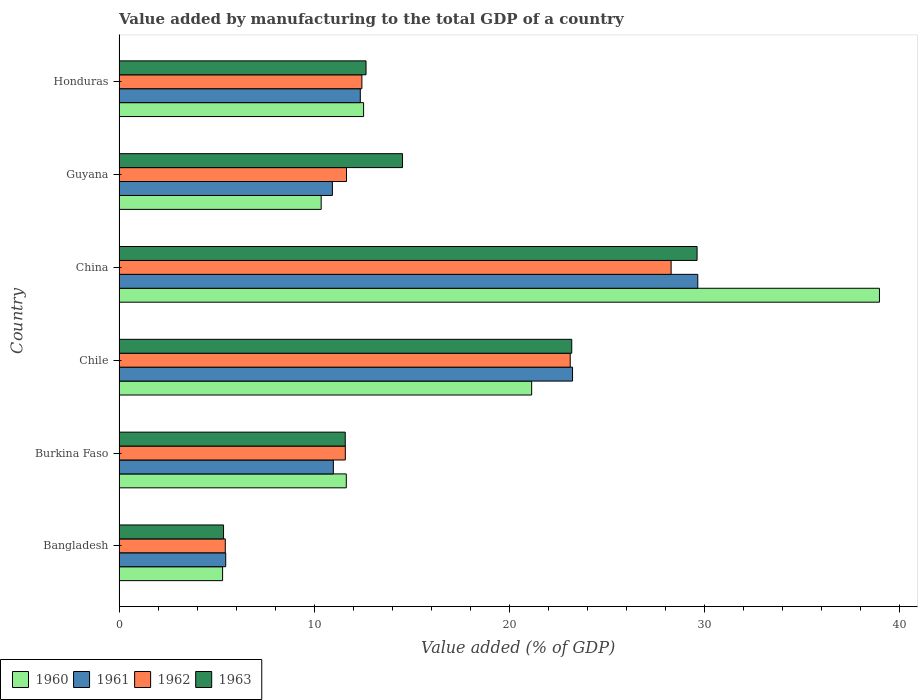How many groups of bars are there?
Make the answer very short. 6. Are the number of bars per tick equal to the number of legend labels?
Provide a succinct answer. Yes. How many bars are there on the 6th tick from the bottom?
Provide a short and direct response. 4. What is the label of the 5th group of bars from the top?
Provide a succinct answer. Burkina Faso. What is the value added by manufacturing to the total GDP in 1961 in Bangladesh?
Your answer should be compact. 5.47. Across all countries, what is the maximum value added by manufacturing to the total GDP in 1962?
Give a very brief answer. 28.31. Across all countries, what is the minimum value added by manufacturing to the total GDP in 1963?
Your answer should be compact. 5.36. What is the total value added by manufacturing to the total GDP in 1963 in the graph?
Ensure brevity in your answer.  97.02. What is the difference between the value added by manufacturing to the total GDP in 1961 in Chile and that in Guyana?
Give a very brief answer. 12.32. What is the difference between the value added by manufacturing to the total GDP in 1963 in Chile and the value added by manufacturing to the total GDP in 1961 in China?
Offer a very short reply. -6.46. What is the average value added by manufacturing to the total GDP in 1961 per country?
Provide a succinct answer. 15.45. What is the difference between the value added by manufacturing to the total GDP in 1960 and value added by manufacturing to the total GDP in 1961 in Guyana?
Your answer should be compact. -0.58. In how many countries, is the value added by manufacturing to the total GDP in 1963 greater than 38 %?
Ensure brevity in your answer.  0. What is the ratio of the value added by manufacturing to the total GDP in 1961 in Guyana to that in Honduras?
Offer a terse response. 0.88. Is the value added by manufacturing to the total GDP in 1963 in Bangladesh less than that in Chile?
Provide a succinct answer. Yes. What is the difference between the highest and the second highest value added by manufacturing to the total GDP in 1962?
Offer a terse response. 5.18. What is the difference between the highest and the lowest value added by manufacturing to the total GDP in 1960?
Your answer should be compact. 33.69. In how many countries, is the value added by manufacturing to the total GDP in 1963 greater than the average value added by manufacturing to the total GDP in 1963 taken over all countries?
Make the answer very short. 2. Is the sum of the value added by manufacturing to the total GDP in 1962 in Chile and Guyana greater than the maximum value added by manufacturing to the total GDP in 1961 across all countries?
Your answer should be very brief. Yes. Is it the case that in every country, the sum of the value added by manufacturing to the total GDP in 1961 and value added by manufacturing to the total GDP in 1963 is greater than the sum of value added by manufacturing to the total GDP in 1962 and value added by manufacturing to the total GDP in 1960?
Ensure brevity in your answer.  No. What does the 4th bar from the top in Guyana represents?
Offer a terse response. 1960. What does the 1st bar from the bottom in Burkina Faso represents?
Your response must be concise. 1960. Is it the case that in every country, the sum of the value added by manufacturing to the total GDP in 1963 and value added by manufacturing to the total GDP in 1961 is greater than the value added by manufacturing to the total GDP in 1960?
Your response must be concise. Yes. How many bars are there?
Provide a succinct answer. 24. What is the difference between two consecutive major ticks on the X-axis?
Your answer should be compact. 10. Does the graph contain any zero values?
Keep it short and to the point. No. How many legend labels are there?
Offer a very short reply. 4. What is the title of the graph?
Give a very brief answer. Value added by manufacturing to the total GDP of a country. Does "1968" appear as one of the legend labels in the graph?
Ensure brevity in your answer.  No. What is the label or title of the X-axis?
Provide a succinct answer. Value added (% of GDP). What is the Value added (% of GDP) in 1960 in Bangladesh?
Your answer should be compact. 5.31. What is the Value added (% of GDP) of 1961 in Bangladesh?
Your response must be concise. 5.47. What is the Value added (% of GDP) in 1962 in Bangladesh?
Ensure brevity in your answer.  5.45. What is the Value added (% of GDP) of 1963 in Bangladesh?
Your answer should be very brief. 5.36. What is the Value added (% of GDP) in 1960 in Burkina Faso?
Keep it short and to the point. 11.65. What is the Value added (% of GDP) in 1961 in Burkina Faso?
Your answer should be compact. 10.99. What is the Value added (% of GDP) of 1962 in Burkina Faso?
Provide a succinct answer. 11.6. What is the Value added (% of GDP) of 1963 in Burkina Faso?
Make the answer very short. 11.6. What is the Value added (% of GDP) in 1960 in Chile?
Offer a terse response. 21.16. What is the Value added (% of GDP) in 1961 in Chile?
Provide a succinct answer. 23.26. What is the Value added (% of GDP) of 1962 in Chile?
Give a very brief answer. 23.14. What is the Value added (% of GDP) of 1963 in Chile?
Give a very brief answer. 23.22. What is the Value added (% of GDP) of 1960 in China?
Your response must be concise. 39. What is the Value added (% of GDP) in 1961 in China?
Your response must be concise. 29.68. What is the Value added (% of GDP) of 1962 in China?
Provide a succinct answer. 28.31. What is the Value added (% of GDP) in 1963 in China?
Your answer should be very brief. 29.64. What is the Value added (% of GDP) in 1960 in Guyana?
Provide a succinct answer. 10.37. What is the Value added (% of GDP) of 1961 in Guyana?
Offer a very short reply. 10.94. What is the Value added (% of GDP) of 1962 in Guyana?
Provide a short and direct response. 11.66. What is the Value added (% of GDP) of 1963 in Guyana?
Provide a succinct answer. 14.54. What is the Value added (% of GDP) in 1960 in Honduras?
Give a very brief answer. 12.54. What is the Value added (% of GDP) of 1961 in Honduras?
Keep it short and to the point. 12.37. What is the Value added (% of GDP) of 1962 in Honduras?
Give a very brief answer. 12.45. What is the Value added (% of GDP) of 1963 in Honduras?
Your answer should be compact. 12.67. Across all countries, what is the maximum Value added (% of GDP) in 1960?
Offer a terse response. 39. Across all countries, what is the maximum Value added (% of GDP) of 1961?
Your answer should be very brief. 29.68. Across all countries, what is the maximum Value added (% of GDP) of 1962?
Your answer should be very brief. 28.31. Across all countries, what is the maximum Value added (% of GDP) of 1963?
Keep it short and to the point. 29.64. Across all countries, what is the minimum Value added (% of GDP) of 1960?
Offer a very short reply. 5.31. Across all countries, what is the minimum Value added (% of GDP) in 1961?
Offer a terse response. 5.47. Across all countries, what is the minimum Value added (% of GDP) in 1962?
Provide a succinct answer. 5.45. Across all countries, what is the minimum Value added (% of GDP) of 1963?
Keep it short and to the point. 5.36. What is the total Value added (% of GDP) in 1960 in the graph?
Your response must be concise. 100.03. What is the total Value added (% of GDP) of 1961 in the graph?
Provide a short and direct response. 92.71. What is the total Value added (% of GDP) in 1962 in the graph?
Your response must be concise. 92.62. What is the total Value added (% of GDP) of 1963 in the graph?
Offer a very short reply. 97.02. What is the difference between the Value added (% of GDP) of 1960 in Bangladesh and that in Burkina Faso?
Keep it short and to the point. -6.34. What is the difference between the Value added (% of GDP) in 1961 in Bangladesh and that in Burkina Faso?
Your response must be concise. -5.52. What is the difference between the Value added (% of GDP) in 1962 in Bangladesh and that in Burkina Faso?
Provide a succinct answer. -6.16. What is the difference between the Value added (% of GDP) of 1963 in Bangladesh and that in Burkina Faso?
Provide a succinct answer. -6.24. What is the difference between the Value added (% of GDP) of 1960 in Bangladesh and that in Chile?
Provide a short and direct response. -15.85. What is the difference between the Value added (% of GDP) of 1961 in Bangladesh and that in Chile?
Your answer should be compact. -17.79. What is the difference between the Value added (% of GDP) in 1962 in Bangladesh and that in Chile?
Keep it short and to the point. -17.69. What is the difference between the Value added (% of GDP) of 1963 in Bangladesh and that in Chile?
Give a very brief answer. -17.86. What is the difference between the Value added (% of GDP) in 1960 in Bangladesh and that in China?
Ensure brevity in your answer.  -33.69. What is the difference between the Value added (% of GDP) in 1961 in Bangladesh and that in China?
Offer a terse response. -24.21. What is the difference between the Value added (% of GDP) in 1962 in Bangladesh and that in China?
Ensure brevity in your answer.  -22.86. What is the difference between the Value added (% of GDP) of 1963 in Bangladesh and that in China?
Your answer should be very brief. -24.28. What is the difference between the Value added (% of GDP) in 1960 in Bangladesh and that in Guyana?
Your answer should be very brief. -5.06. What is the difference between the Value added (% of GDP) in 1961 in Bangladesh and that in Guyana?
Provide a short and direct response. -5.47. What is the difference between the Value added (% of GDP) of 1962 in Bangladesh and that in Guyana?
Provide a short and direct response. -6.22. What is the difference between the Value added (% of GDP) of 1963 in Bangladesh and that in Guyana?
Make the answer very short. -9.18. What is the difference between the Value added (% of GDP) in 1960 in Bangladesh and that in Honduras?
Your answer should be compact. -7.23. What is the difference between the Value added (% of GDP) of 1961 in Bangladesh and that in Honduras?
Provide a succinct answer. -6.9. What is the difference between the Value added (% of GDP) of 1962 in Bangladesh and that in Honduras?
Make the answer very short. -7.01. What is the difference between the Value added (% of GDP) of 1963 in Bangladesh and that in Honduras?
Keep it short and to the point. -7.31. What is the difference between the Value added (% of GDP) in 1960 in Burkina Faso and that in Chile?
Keep it short and to the point. -9.51. What is the difference between the Value added (% of GDP) of 1961 in Burkina Faso and that in Chile?
Offer a very short reply. -12.27. What is the difference between the Value added (% of GDP) of 1962 in Burkina Faso and that in Chile?
Your response must be concise. -11.53. What is the difference between the Value added (% of GDP) in 1963 in Burkina Faso and that in Chile?
Your answer should be compact. -11.62. What is the difference between the Value added (% of GDP) of 1960 in Burkina Faso and that in China?
Make the answer very short. -27.34. What is the difference between the Value added (% of GDP) in 1961 in Burkina Faso and that in China?
Make the answer very short. -18.69. What is the difference between the Value added (% of GDP) of 1962 in Burkina Faso and that in China?
Your response must be concise. -16.71. What is the difference between the Value added (% of GDP) of 1963 in Burkina Faso and that in China?
Ensure brevity in your answer.  -18.04. What is the difference between the Value added (% of GDP) in 1960 in Burkina Faso and that in Guyana?
Provide a succinct answer. 1.29. What is the difference between the Value added (% of GDP) of 1961 in Burkina Faso and that in Guyana?
Your response must be concise. 0.05. What is the difference between the Value added (% of GDP) in 1962 in Burkina Faso and that in Guyana?
Provide a short and direct response. -0.06. What is the difference between the Value added (% of GDP) of 1963 in Burkina Faso and that in Guyana?
Your answer should be compact. -2.94. What is the difference between the Value added (% of GDP) of 1960 in Burkina Faso and that in Honduras?
Your answer should be very brief. -0.89. What is the difference between the Value added (% of GDP) of 1961 in Burkina Faso and that in Honduras?
Ensure brevity in your answer.  -1.38. What is the difference between the Value added (% of GDP) in 1962 in Burkina Faso and that in Honduras?
Your answer should be compact. -0.85. What is the difference between the Value added (% of GDP) in 1963 in Burkina Faso and that in Honduras?
Your response must be concise. -1.07. What is the difference between the Value added (% of GDP) of 1960 in Chile and that in China?
Offer a terse response. -17.84. What is the difference between the Value added (% of GDP) of 1961 in Chile and that in China?
Provide a succinct answer. -6.42. What is the difference between the Value added (% of GDP) in 1962 in Chile and that in China?
Your response must be concise. -5.17. What is the difference between the Value added (% of GDP) in 1963 in Chile and that in China?
Make the answer very short. -6.43. What is the difference between the Value added (% of GDP) of 1960 in Chile and that in Guyana?
Ensure brevity in your answer.  10.79. What is the difference between the Value added (% of GDP) of 1961 in Chile and that in Guyana?
Provide a succinct answer. 12.32. What is the difference between the Value added (% of GDP) of 1962 in Chile and that in Guyana?
Give a very brief answer. 11.47. What is the difference between the Value added (% of GDP) in 1963 in Chile and that in Guyana?
Your answer should be very brief. 8.68. What is the difference between the Value added (% of GDP) in 1960 in Chile and that in Honduras?
Offer a very short reply. 8.62. What is the difference between the Value added (% of GDP) in 1961 in Chile and that in Honduras?
Your answer should be very brief. 10.88. What is the difference between the Value added (% of GDP) of 1962 in Chile and that in Honduras?
Your answer should be very brief. 10.68. What is the difference between the Value added (% of GDP) of 1963 in Chile and that in Honduras?
Offer a terse response. 10.55. What is the difference between the Value added (% of GDP) in 1960 in China and that in Guyana?
Your answer should be very brief. 28.63. What is the difference between the Value added (% of GDP) of 1961 in China and that in Guyana?
Your answer should be compact. 18.74. What is the difference between the Value added (% of GDP) of 1962 in China and that in Guyana?
Your response must be concise. 16.65. What is the difference between the Value added (% of GDP) in 1963 in China and that in Guyana?
Provide a short and direct response. 15.11. What is the difference between the Value added (% of GDP) of 1960 in China and that in Honduras?
Offer a terse response. 26.46. What is the difference between the Value added (% of GDP) of 1961 in China and that in Honduras?
Offer a very short reply. 17.31. What is the difference between the Value added (% of GDP) of 1962 in China and that in Honduras?
Offer a very short reply. 15.86. What is the difference between the Value added (% of GDP) of 1963 in China and that in Honduras?
Your answer should be very brief. 16.98. What is the difference between the Value added (% of GDP) of 1960 in Guyana and that in Honduras?
Your response must be concise. -2.18. What is the difference between the Value added (% of GDP) in 1961 in Guyana and that in Honduras?
Make the answer very short. -1.43. What is the difference between the Value added (% of GDP) of 1962 in Guyana and that in Honduras?
Make the answer very short. -0.79. What is the difference between the Value added (% of GDP) of 1963 in Guyana and that in Honduras?
Keep it short and to the point. 1.87. What is the difference between the Value added (% of GDP) in 1960 in Bangladesh and the Value added (% of GDP) in 1961 in Burkina Faso?
Give a very brief answer. -5.68. What is the difference between the Value added (% of GDP) of 1960 in Bangladesh and the Value added (% of GDP) of 1962 in Burkina Faso?
Your answer should be very brief. -6.29. What is the difference between the Value added (% of GDP) in 1960 in Bangladesh and the Value added (% of GDP) in 1963 in Burkina Faso?
Make the answer very short. -6.29. What is the difference between the Value added (% of GDP) of 1961 in Bangladesh and the Value added (% of GDP) of 1962 in Burkina Faso?
Your response must be concise. -6.13. What is the difference between the Value added (% of GDP) in 1961 in Bangladesh and the Value added (% of GDP) in 1963 in Burkina Faso?
Offer a very short reply. -6.13. What is the difference between the Value added (% of GDP) of 1962 in Bangladesh and the Value added (% of GDP) of 1963 in Burkina Faso?
Your answer should be compact. -6.15. What is the difference between the Value added (% of GDP) of 1960 in Bangladesh and the Value added (% of GDP) of 1961 in Chile?
Your answer should be compact. -17.95. What is the difference between the Value added (% of GDP) in 1960 in Bangladesh and the Value added (% of GDP) in 1962 in Chile?
Your answer should be compact. -17.83. What is the difference between the Value added (% of GDP) of 1960 in Bangladesh and the Value added (% of GDP) of 1963 in Chile?
Provide a short and direct response. -17.91. What is the difference between the Value added (% of GDP) of 1961 in Bangladesh and the Value added (% of GDP) of 1962 in Chile?
Give a very brief answer. -17.67. What is the difference between the Value added (% of GDP) in 1961 in Bangladesh and the Value added (% of GDP) in 1963 in Chile?
Your answer should be very brief. -17.75. What is the difference between the Value added (% of GDP) of 1962 in Bangladesh and the Value added (% of GDP) of 1963 in Chile?
Your answer should be very brief. -17.77. What is the difference between the Value added (% of GDP) in 1960 in Bangladesh and the Value added (% of GDP) in 1961 in China?
Keep it short and to the point. -24.37. What is the difference between the Value added (% of GDP) of 1960 in Bangladesh and the Value added (% of GDP) of 1962 in China?
Provide a short and direct response. -23. What is the difference between the Value added (% of GDP) in 1960 in Bangladesh and the Value added (% of GDP) in 1963 in China?
Keep it short and to the point. -24.33. What is the difference between the Value added (% of GDP) of 1961 in Bangladesh and the Value added (% of GDP) of 1962 in China?
Your answer should be compact. -22.84. What is the difference between the Value added (% of GDP) of 1961 in Bangladesh and the Value added (% of GDP) of 1963 in China?
Provide a succinct answer. -24.17. What is the difference between the Value added (% of GDP) in 1962 in Bangladesh and the Value added (% of GDP) in 1963 in China?
Keep it short and to the point. -24.2. What is the difference between the Value added (% of GDP) of 1960 in Bangladesh and the Value added (% of GDP) of 1961 in Guyana?
Your response must be concise. -5.63. What is the difference between the Value added (% of GDP) of 1960 in Bangladesh and the Value added (% of GDP) of 1962 in Guyana?
Your answer should be compact. -6.35. What is the difference between the Value added (% of GDP) in 1960 in Bangladesh and the Value added (% of GDP) in 1963 in Guyana?
Give a very brief answer. -9.23. What is the difference between the Value added (% of GDP) in 1961 in Bangladesh and the Value added (% of GDP) in 1962 in Guyana?
Your answer should be very brief. -6.19. What is the difference between the Value added (% of GDP) in 1961 in Bangladesh and the Value added (% of GDP) in 1963 in Guyana?
Your answer should be very brief. -9.07. What is the difference between the Value added (% of GDP) of 1962 in Bangladesh and the Value added (% of GDP) of 1963 in Guyana?
Your answer should be very brief. -9.09. What is the difference between the Value added (% of GDP) of 1960 in Bangladesh and the Value added (% of GDP) of 1961 in Honduras?
Offer a terse response. -7.06. What is the difference between the Value added (% of GDP) of 1960 in Bangladesh and the Value added (% of GDP) of 1962 in Honduras?
Your answer should be very brief. -7.14. What is the difference between the Value added (% of GDP) in 1960 in Bangladesh and the Value added (% of GDP) in 1963 in Honduras?
Your answer should be compact. -7.36. What is the difference between the Value added (% of GDP) of 1961 in Bangladesh and the Value added (% of GDP) of 1962 in Honduras?
Your response must be concise. -6.98. What is the difference between the Value added (% of GDP) of 1961 in Bangladesh and the Value added (% of GDP) of 1963 in Honduras?
Provide a short and direct response. -7.2. What is the difference between the Value added (% of GDP) of 1962 in Bangladesh and the Value added (% of GDP) of 1963 in Honduras?
Your answer should be compact. -7.22. What is the difference between the Value added (% of GDP) of 1960 in Burkina Faso and the Value added (% of GDP) of 1961 in Chile?
Ensure brevity in your answer.  -11.6. What is the difference between the Value added (% of GDP) in 1960 in Burkina Faso and the Value added (% of GDP) in 1962 in Chile?
Offer a very short reply. -11.48. What is the difference between the Value added (% of GDP) in 1960 in Burkina Faso and the Value added (% of GDP) in 1963 in Chile?
Provide a succinct answer. -11.56. What is the difference between the Value added (% of GDP) of 1961 in Burkina Faso and the Value added (% of GDP) of 1962 in Chile?
Offer a terse response. -12.15. What is the difference between the Value added (% of GDP) of 1961 in Burkina Faso and the Value added (% of GDP) of 1963 in Chile?
Offer a terse response. -12.23. What is the difference between the Value added (% of GDP) of 1962 in Burkina Faso and the Value added (% of GDP) of 1963 in Chile?
Give a very brief answer. -11.61. What is the difference between the Value added (% of GDP) in 1960 in Burkina Faso and the Value added (% of GDP) in 1961 in China?
Your response must be concise. -18.03. What is the difference between the Value added (% of GDP) of 1960 in Burkina Faso and the Value added (% of GDP) of 1962 in China?
Your response must be concise. -16.66. What is the difference between the Value added (% of GDP) in 1960 in Burkina Faso and the Value added (% of GDP) in 1963 in China?
Offer a very short reply. -17.99. What is the difference between the Value added (% of GDP) of 1961 in Burkina Faso and the Value added (% of GDP) of 1962 in China?
Your answer should be compact. -17.32. What is the difference between the Value added (% of GDP) in 1961 in Burkina Faso and the Value added (% of GDP) in 1963 in China?
Your answer should be very brief. -18.65. What is the difference between the Value added (% of GDP) in 1962 in Burkina Faso and the Value added (% of GDP) in 1963 in China?
Provide a succinct answer. -18.04. What is the difference between the Value added (% of GDP) in 1960 in Burkina Faso and the Value added (% of GDP) in 1961 in Guyana?
Provide a short and direct response. 0.71. What is the difference between the Value added (% of GDP) in 1960 in Burkina Faso and the Value added (% of GDP) in 1962 in Guyana?
Your answer should be compact. -0.01. What is the difference between the Value added (% of GDP) of 1960 in Burkina Faso and the Value added (% of GDP) of 1963 in Guyana?
Offer a very short reply. -2.88. What is the difference between the Value added (% of GDP) in 1961 in Burkina Faso and the Value added (% of GDP) in 1962 in Guyana?
Provide a short and direct response. -0.67. What is the difference between the Value added (% of GDP) of 1961 in Burkina Faso and the Value added (% of GDP) of 1963 in Guyana?
Give a very brief answer. -3.55. What is the difference between the Value added (% of GDP) in 1962 in Burkina Faso and the Value added (% of GDP) in 1963 in Guyana?
Give a very brief answer. -2.93. What is the difference between the Value added (% of GDP) of 1960 in Burkina Faso and the Value added (% of GDP) of 1961 in Honduras?
Your answer should be compact. -0.72. What is the difference between the Value added (% of GDP) in 1960 in Burkina Faso and the Value added (% of GDP) in 1962 in Honduras?
Your response must be concise. -0.8. What is the difference between the Value added (% of GDP) of 1960 in Burkina Faso and the Value added (% of GDP) of 1963 in Honduras?
Provide a short and direct response. -1.01. What is the difference between the Value added (% of GDP) of 1961 in Burkina Faso and the Value added (% of GDP) of 1962 in Honduras?
Ensure brevity in your answer.  -1.46. What is the difference between the Value added (% of GDP) of 1961 in Burkina Faso and the Value added (% of GDP) of 1963 in Honduras?
Offer a very short reply. -1.68. What is the difference between the Value added (% of GDP) in 1962 in Burkina Faso and the Value added (% of GDP) in 1963 in Honduras?
Provide a short and direct response. -1.06. What is the difference between the Value added (% of GDP) of 1960 in Chile and the Value added (% of GDP) of 1961 in China?
Offer a terse response. -8.52. What is the difference between the Value added (% of GDP) in 1960 in Chile and the Value added (% of GDP) in 1962 in China?
Provide a short and direct response. -7.15. What is the difference between the Value added (% of GDP) in 1960 in Chile and the Value added (% of GDP) in 1963 in China?
Offer a terse response. -8.48. What is the difference between the Value added (% of GDP) of 1961 in Chile and the Value added (% of GDP) of 1962 in China?
Provide a short and direct response. -5.06. What is the difference between the Value added (% of GDP) in 1961 in Chile and the Value added (% of GDP) in 1963 in China?
Give a very brief answer. -6.39. What is the difference between the Value added (% of GDP) of 1962 in Chile and the Value added (% of GDP) of 1963 in China?
Provide a succinct answer. -6.51. What is the difference between the Value added (% of GDP) in 1960 in Chile and the Value added (% of GDP) in 1961 in Guyana?
Provide a succinct answer. 10.22. What is the difference between the Value added (% of GDP) of 1960 in Chile and the Value added (% of GDP) of 1962 in Guyana?
Offer a very short reply. 9.5. What is the difference between the Value added (% of GDP) in 1960 in Chile and the Value added (% of GDP) in 1963 in Guyana?
Keep it short and to the point. 6.62. What is the difference between the Value added (% of GDP) in 1961 in Chile and the Value added (% of GDP) in 1962 in Guyana?
Offer a very short reply. 11.59. What is the difference between the Value added (% of GDP) of 1961 in Chile and the Value added (% of GDP) of 1963 in Guyana?
Provide a short and direct response. 8.72. What is the difference between the Value added (% of GDP) in 1962 in Chile and the Value added (% of GDP) in 1963 in Guyana?
Your answer should be very brief. 8.6. What is the difference between the Value added (% of GDP) in 1960 in Chile and the Value added (% of GDP) in 1961 in Honduras?
Make the answer very short. 8.79. What is the difference between the Value added (% of GDP) of 1960 in Chile and the Value added (% of GDP) of 1962 in Honduras?
Ensure brevity in your answer.  8.71. What is the difference between the Value added (% of GDP) of 1960 in Chile and the Value added (% of GDP) of 1963 in Honduras?
Provide a short and direct response. 8.49. What is the difference between the Value added (% of GDP) in 1961 in Chile and the Value added (% of GDP) in 1962 in Honduras?
Make the answer very short. 10.8. What is the difference between the Value added (% of GDP) in 1961 in Chile and the Value added (% of GDP) in 1963 in Honduras?
Make the answer very short. 10.59. What is the difference between the Value added (% of GDP) of 1962 in Chile and the Value added (% of GDP) of 1963 in Honduras?
Your response must be concise. 10.47. What is the difference between the Value added (% of GDP) of 1960 in China and the Value added (% of GDP) of 1961 in Guyana?
Offer a very short reply. 28.06. What is the difference between the Value added (% of GDP) of 1960 in China and the Value added (% of GDP) of 1962 in Guyana?
Ensure brevity in your answer.  27.33. What is the difference between the Value added (% of GDP) of 1960 in China and the Value added (% of GDP) of 1963 in Guyana?
Offer a terse response. 24.46. What is the difference between the Value added (% of GDP) of 1961 in China and the Value added (% of GDP) of 1962 in Guyana?
Your answer should be compact. 18.02. What is the difference between the Value added (% of GDP) in 1961 in China and the Value added (% of GDP) in 1963 in Guyana?
Your response must be concise. 15.14. What is the difference between the Value added (% of GDP) of 1962 in China and the Value added (% of GDP) of 1963 in Guyana?
Provide a succinct answer. 13.78. What is the difference between the Value added (% of GDP) of 1960 in China and the Value added (% of GDP) of 1961 in Honduras?
Offer a very short reply. 26.63. What is the difference between the Value added (% of GDP) in 1960 in China and the Value added (% of GDP) in 1962 in Honduras?
Offer a very short reply. 26.54. What is the difference between the Value added (% of GDP) of 1960 in China and the Value added (% of GDP) of 1963 in Honduras?
Make the answer very short. 26.33. What is the difference between the Value added (% of GDP) of 1961 in China and the Value added (% of GDP) of 1962 in Honduras?
Offer a very short reply. 17.23. What is the difference between the Value added (% of GDP) of 1961 in China and the Value added (% of GDP) of 1963 in Honduras?
Your response must be concise. 17.01. What is the difference between the Value added (% of GDP) of 1962 in China and the Value added (% of GDP) of 1963 in Honduras?
Offer a very short reply. 15.65. What is the difference between the Value added (% of GDP) in 1960 in Guyana and the Value added (% of GDP) in 1961 in Honduras?
Your answer should be very brief. -2.01. What is the difference between the Value added (% of GDP) of 1960 in Guyana and the Value added (% of GDP) of 1962 in Honduras?
Your answer should be very brief. -2.09. What is the difference between the Value added (% of GDP) in 1960 in Guyana and the Value added (% of GDP) in 1963 in Honduras?
Your answer should be very brief. -2.3. What is the difference between the Value added (% of GDP) in 1961 in Guyana and the Value added (% of GDP) in 1962 in Honduras?
Your answer should be very brief. -1.51. What is the difference between the Value added (% of GDP) of 1961 in Guyana and the Value added (% of GDP) of 1963 in Honduras?
Offer a very short reply. -1.73. What is the difference between the Value added (% of GDP) in 1962 in Guyana and the Value added (% of GDP) in 1963 in Honduras?
Offer a very short reply. -1. What is the average Value added (% of GDP) of 1960 per country?
Offer a terse response. 16.67. What is the average Value added (% of GDP) of 1961 per country?
Provide a succinct answer. 15.45. What is the average Value added (% of GDP) of 1962 per country?
Your response must be concise. 15.44. What is the average Value added (% of GDP) of 1963 per country?
Provide a short and direct response. 16.17. What is the difference between the Value added (% of GDP) of 1960 and Value added (% of GDP) of 1961 in Bangladesh?
Keep it short and to the point. -0.16. What is the difference between the Value added (% of GDP) in 1960 and Value added (% of GDP) in 1962 in Bangladesh?
Provide a succinct answer. -0.14. What is the difference between the Value added (% of GDP) in 1960 and Value added (% of GDP) in 1963 in Bangladesh?
Offer a very short reply. -0.05. What is the difference between the Value added (% of GDP) of 1961 and Value added (% of GDP) of 1962 in Bangladesh?
Provide a short and direct response. 0.02. What is the difference between the Value added (% of GDP) in 1961 and Value added (% of GDP) in 1963 in Bangladesh?
Give a very brief answer. 0.11. What is the difference between the Value added (% of GDP) in 1962 and Value added (% of GDP) in 1963 in Bangladesh?
Ensure brevity in your answer.  0.09. What is the difference between the Value added (% of GDP) in 1960 and Value added (% of GDP) in 1961 in Burkina Faso?
Your response must be concise. 0.66. What is the difference between the Value added (% of GDP) of 1960 and Value added (% of GDP) of 1962 in Burkina Faso?
Make the answer very short. 0.05. What is the difference between the Value added (% of GDP) in 1960 and Value added (% of GDP) in 1963 in Burkina Faso?
Make the answer very short. 0.05. What is the difference between the Value added (% of GDP) of 1961 and Value added (% of GDP) of 1962 in Burkina Faso?
Give a very brief answer. -0.61. What is the difference between the Value added (% of GDP) in 1961 and Value added (% of GDP) in 1963 in Burkina Faso?
Give a very brief answer. -0.61. What is the difference between the Value added (% of GDP) of 1962 and Value added (% of GDP) of 1963 in Burkina Faso?
Ensure brevity in your answer.  0. What is the difference between the Value added (% of GDP) in 1960 and Value added (% of GDP) in 1961 in Chile?
Your response must be concise. -2.1. What is the difference between the Value added (% of GDP) in 1960 and Value added (% of GDP) in 1962 in Chile?
Provide a succinct answer. -1.98. What is the difference between the Value added (% of GDP) in 1960 and Value added (% of GDP) in 1963 in Chile?
Make the answer very short. -2.06. What is the difference between the Value added (% of GDP) in 1961 and Value added (% of GDP) in 1962 in Chile?
Provide a short and direct response. 0.12. What is the difference between the Value added (% of GDP) in 1961 and Value added (% of GDP) in 1963 in Chile?
Offer a terse response. 0.04. What is the difference between the Value added (% of GDP) of 1962 and Value added (% of GDP) of 1963 in Chile?
Provide a short and direct response. -0.08. What is the difference between the Value added (% of GDP) of 1960 and Value added (% of GDP) of 1961 in China?
Provide a short and direct response. 9.32. What is the difference between the Value added (% of GDP) of 1960 and Value added (% of GDP) of 1962 in China?
Keep it short and to the point. 10.69. What is the difference between the Value added (% of GDP) in 1960 and Value added (% of GDP) in 1963 in China?
Offer a very short reply. 9.35. What is the difference between the Value added (% of GDP) of 1961 and Value added (% of GDP) of 1962 in China?
Make the answer very short. 1.37. What is the difference between the Value added (% of GDP) of 1961 and Value added (% of GDP) of 1963 in China?
Your response must be concise. 0.04. What is the difference between the Value added (% of GDP) of 1962 and Value added (% of GDP) of 1963 in China?
Offer a terse response. -1.33. What is the difference between the Value added (% of GDP) in 1960 and Value added (% of GDP) in 1961 in Guyana?
Make the answer very short. -0.58. What is the difference between the Value added (% of GDP) of 1960 and Value added (% of GDP) of 1962 in Guyana?
Provide a short and direct response. -1.3. What is the difference between the Value added (% of GDP) of 1960 and Value added (% of GDP) of 1963 in Guyana?
Provide a short and direct response. -4.17. What is the difference between the Value added (% of GDP) in 1961 and Value added (% of GDP) in 1962 in Guyana?
Give a very brief answer. -0.72. What is the difference between the Value added (% of GDP) of 1961 and Value added (% of GDP) of 1963 in Guyana?
Keep it short and to the point. -3.6. What is the difference between the Value added (% of GDP) in 1962 and Value added (% of GDP) in 1963 in Guyana?
Provide a short and direct response. -2.87. What is the difference between the Value added (% of GDP) in 1960 and Value added (% of GDP) in 1961 in Honduras?
Offer a terse response. 0.17. What is the difference between the Value added (% of GDP) of 1960 and Value added (% of GDP) of 1962 in Honduras?
Offer a terse response. 0.09. What is the difference between the Value added (% of GDP) in 1960 and Value added (% of GDP) in 1963 in Honduras?
Offer a terse response. -0.13. What is the difference between the Value added (% of GDP) of 1961 and Value added (% of GDP) of 1962 in Honduras?
Provide a short and direct response. -0.08. What is the difference between the Value added (% of GDP) of 1961 and Value added (% of GDP) of 1963 in Honduras?
Offer a very short reply. -0.29. What is the difference between the Value added (% of GDP) in 1962 and Value added (% of GDP) in 1963 in Honduras?
Provide a succinct answer. -0.21. What is the ratio of the Value added (% of GDP) of 1960 in Bangladesh to that in Burkina Faso?
Provide a succinct answer. 0.46. What is the ratio of the Value added (% of GDP) of 1961 in Bangladesh to that in Burkina Faso?
Your answer should be very brief. 0.5. What is the ratio of the Value added (% of GDP) in 1962 in Bangladesh to that in Burkina Faso?
Your response must be concise. 0.47. What is the ratio of the Value added (% of GDP) of 1963 in Bangladesh to that in Burkina Faso?
Your answer should be compact. 0.46. What is the ratio of the Value added (% of GDP) in 1960 in Bangladesh to that in Chile?
Offer a very short reply. 0.25. What is the ratio of the Value added (% of GDP) of 1961 in Bangladesh to that in Chile?
Make the answer very short. 0.24. What is the ratio of the Value added (% of GDP) of 1962 in Bangladesh to that in Chile?
Your response must be concise. 0.24. What is the ratio of the Value added (% of GDP) of 1963 in Bangladesh to that in Chile?
Offer a very short reply. 0.23. What is the ratio of the Value added (% of GDP) of 1960 in Bangladesh to that in China?
Give a very brief answer. 0.14. What is the ratio of the Value added (% of GDP) in 1961 in Bangladesh to that in China?
Give a very brief answer. 0.18. What is the ratio of the Value added (% of GDP) in 1962 in Bangladesh to that in China?
Offer a very short reply. 0.19. What is the ratio of the Value added (% of GDP) in 1963 in Bangladesh to that in China?
Ensure brevity in your answer.  0.18. What is the ratio of the Value added (% of GDP) of 1960 in Bangladesh to that in Guyana?
Offer a terse response. 0.51. What is the ratio of the Value added (% of GDP) in 1962 in Bangladesh to that in Guyana?
Keep it short and to the point. 0.47. What is the ratio of the Value added (% of GDP) in 1963 in Bangladesh to that in Guyana?
Offer a terse response. 0.37. What is the ratio of the Value added (% of GDP) in 1960 in Bangladesh to that in Honduras?
Your answer should be very brief. 0.42. What is the ratio of the Value added (% of GDP) in 1961 in Bangladesh to that in Honduras?
Make the answer very short. 0.44. What is the ratio of the Value added (% of GDP) of 1962 in Bangladesh to that in Honduras?
Offer a very short reply. 0.44. What is the ratio of the Value added (% of GDP) of 1963 in Bangladesh to that in Honduras?
Make the answer very short. 0.42. What is the ratio of the Value added (% of GDP) of 1960 in Burkina Faso to that in Chile?
Give a very brief answer. 0.55. What is the ratio of the Value added (% of GDP) of 1961 in Burkina Faso to that in Chile?
Your response must be concise. 0.47. What is the ratio of the Value added (% of GDP) of 1962 in Burkina Faso to that in Chile?
Make the answer very short. 0.5. What is the ratio of the Value added (% of GDP) of 1963 in Burkina Faso to that in Chile?
Your answer should be compact. 0.5. What is the ratio of the Value added (% of GDP) of 1960 in Burkina Faso to that in China?
Provide a succinct answer. 0.3. What is the ratio of the Value added (% of GDP) in 1961 in Burkina Faso to that in China?
Keep it short and to the point. 0.37. What is the ratio of the Value added (% of GDP) of 1962 in Burkina Faso to that in China?
Offer a terse response. 0.41. What is the ratio of the Value added (% of GDP) in 1963 in Burkina Faso to that in China?
Provide a succinct answer. 0.39. What is the ratio of the Value added (% of GDP) in 1960 in Burkina Faso to that in Guyana?
Ensure brevity in your answer.  1.12. What is the ratio of the Value added (% of GDP) of 1962 in Burkina Faso to that in Guyana?
Offer a very short reply. 0.99. What is the ratio of the Value added (% of GDP) of 1963 in Burkina Faso to that in Guyana?
Give a very brief answer. 0.8. What is the ratio of the Value added (% of GDP) of 1960 in Burkina Faso to that in Honduras?
Offer a terse response. 0.93. What is the ratio of the Value added (% of GDP) of 1961 in Burkina Faso to that in Honduras?
Your answer should be very brief. 0.89. What is the ratio of the Value added (% of GDP) in 1962 in Burkina Faso to that in Honduras?
Offer a very short reply. 0.93. What is the ratio of the Value added (% of GDP) in 1963 in Burkina Faso to that in Honduras?
Provide a short and direct response. 0.92. What is the ratio of the Value added (% of GDP) in 1960 in Chile to that in China?
Provide a short and direct response. 0.54. What is the ratio of the Value added (% of GDP) in 1961 in Chile to that in China?
Give a very brief answer. 0.78. What is the ratio of the Value added (% of GDP) of 1962 in Chile to that in China?
Provide a succinct answer. 0.82. What is the ratio of the Value added (% of GDP) in 1963 in Chile to that in China?
Provide a succinct answer. 0.78. What is the ratio of the Value added (% of GDP) of 1960 in Chile to that in Guyana?
Ensure brevity in your answer.  2.04. What is the ratio of the Value added (% of GDP) in 1961 in Chile to that in Guyana?
Give a very brief answer. 2.13. What is the ratio of the Value added (% of GDP) in 1962 in Chile to that in Guyana?
Provide a succinct answer. 1.98. What is the ratio of the Value added (% of GDP) of 1963 in Chile to that in Guyana?
Your response must be concise. 1.6. What is the ratio of the Value added (% of GDP) of 1960 in Chile to that in Honduras?
Your response must be concise. 1.69. What is the ratio of the Value added (% of GDP) of 1961 in Chile to that in Honduras?
Your answer should be compact. 1.88. What is the ratio of the Value added (% of GDP) of 1962 in Chile to that in Honduras?
Make the answer very short. 1.86. What is the ratio of the Value added (% of GDP) in 1963 in Chile to that in Honduras?
Make the answer very short. 1.83. What is the ratio of the Value added (% of GDP) of 1960 in China to that in Guyana?
Make the answer very short. 3.76. What is the ratio of the Value added (% of GDP) in 1961 in China to that in Guyana?
Offer a terse response. 2.71. What is the ratio of the Value added (% of GDP) of 1962 in China to that in Guyana?
Your answer should be very brief. 2.43. What is the ratio of the Value added (% of GDP) of 1963 in China to that in Guyana?
Ensure brevity in your answer.  2.04. What is the ratio of the Value added (% of GDP) of 1960 in China to that in Honduras?
Provide a short and direct response. 3.11. What is the ratio of the Value added (% of GDP) of 1961 in China to that in Honduras?
Your response must be concise. 2.4. What is the ratio of the Value added (% of GDP) of 1962 in China to that in Honduras?
Offer a terse response. 2.27. What is the ratio of the Value added (% of GDP) of 1963 in China to that in Honduras?
Your answer should be compact. 2.34. What is the ratio of the Value added (% of GDP) of 1960 in Guyana to that in Honduras?
Give a very brief answer. 0.83. What is the ratio of the Value added (% of GDP) in 1961 in Guyana to that in Honduras?
Your answer should be compact. 0.88. What is the ratio of the Value added (% of GDP) of 1962 in Guyana to that in Honduras?
Offer a terse response. 0.94. What is the ratio of the Value added (% of GDP) in 1963 in Guyana to that in Honduras?
Ensure brevity in your answer.  1.15. What is the difference between the highest and the second highest Value added (% of GDP) of 1960?
Make the answer very short. 17.84. What is the difference between the highest and the second highest Value added (% of GDP) in 1961?
Your answer should be very brief. 6.42. What is the difference between the highest and the second highest Value added (% of GDP) in 1962?
Provide a succinct answer. 5.17. What is the difference between the highest and the second highest Value added (% of GDP) in 1963?
Your answer should be very brief. 6.43. What is the difference between the highest and the lowest Value added (% of GDP) in 1960?
Ensure brevity in your answer.  33.69. What is the difference between the highest and the lowest Value added (% of GDP) in 1961?
Ensure brevity in your answer.  24.21. What is the difference between the highest and the lowest Value added (% of GDP) in 1962?
Give a very brief answer. 22.86. What is the difference between the highest and the lowest Value added (% of GDP) in 1963?
Keep it short and to the point. 24.28. 